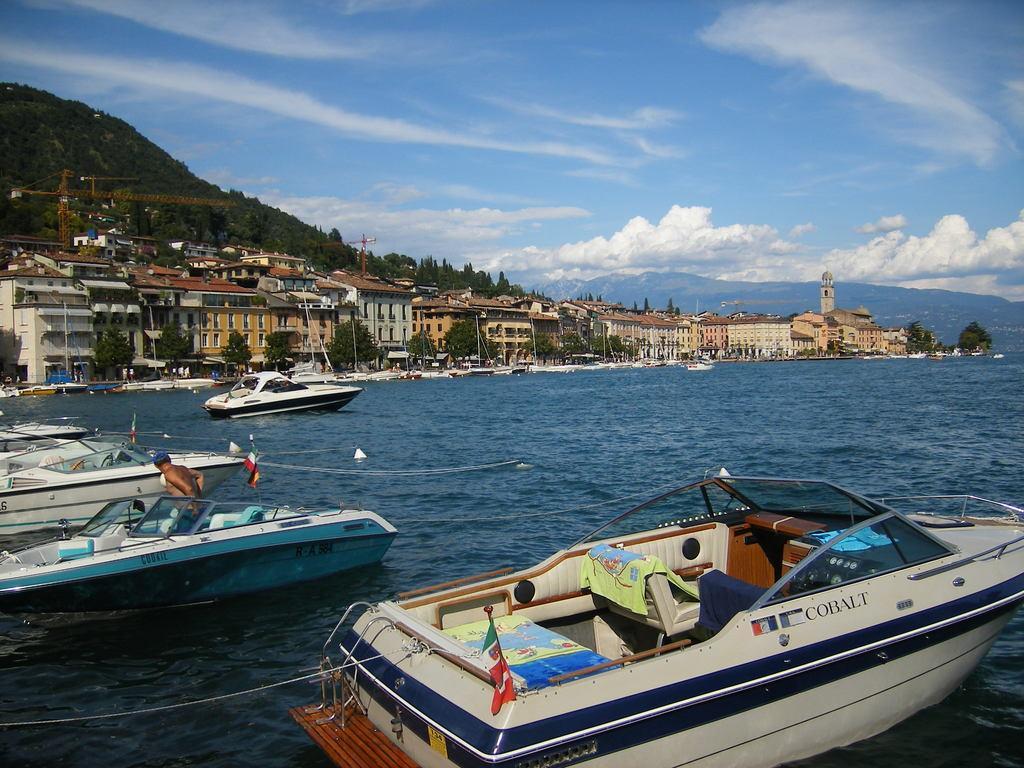In one or two sentences, can you explain what this image depicts? At the bottom there is a boat on the water. On the left a man is standing in the boat on the water. In the background there are boats on the water,poles,buildings,windows,trees,cranes,mountains and clouds in the sky. 